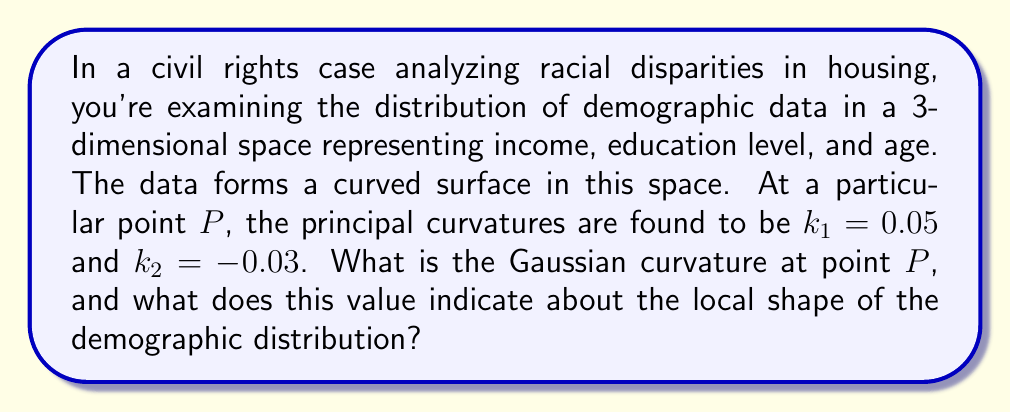Can you answer this question? To solve this problem, we'll follow these steps:

1) Recall that the Gaussian curvature $K$ is defined as the product of the principal curvatures:

   $$K = k_1 \cdot k_2$$

2) We are given:
   $k_1 = 0.05$
   $k_2 = -0.03$

3) Substituting these values into the formula:

   $$K = 0.05 \cdot (-0.03) = -0.0015$$

4) Interpret the result:
   - The Gaussian curvature is negative, which indicates a saddle-like shape at point $P$.
   - In the context of demographic data, this suggests that at this particular combination of income, education level, and age:
     a) The distribution curves upward in one principal direction (perhaps indicating a positive correlation)
     b) Simultaneously, it curves downward in the perpendicular direction (suggesting a negative correlation)
   - This saddle shape implies a complex relationship between the variables at this point, where changes in one variable may have different effects depending on the direction of change in the other variables.

5) For civil rights attorneys, this information could be crucial in understanding and presenting the complexities of demographic distributions, potentially highlighting areas where seemingly positive trends in one aspect might be offset by negative trends in another.
Answer: $K = -0.0015$, indicating a saddle point in the demographic distribution. 